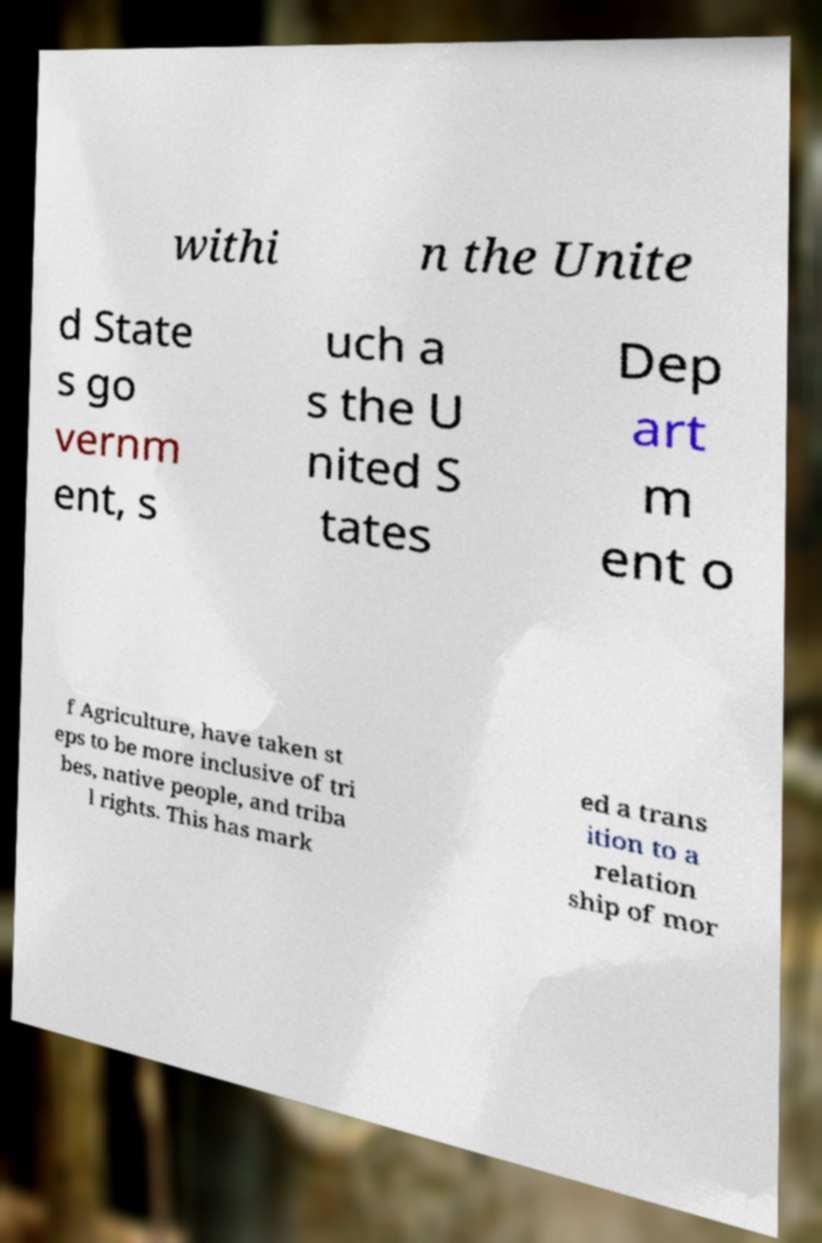Could you assist in decoding the text presented in this image and type it out clearly? withi n the Unite d State s go vernm ent, s uch a s the U nited S tates Dep art m ent o f Agriculture, have taken st eps to be more inclusive of tri bes, native people, and triba l rights. This has mark ed a trans ition to a relation ship of mor 